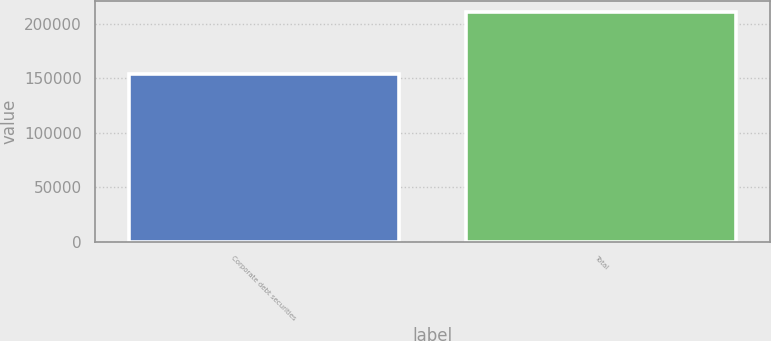Convert chart to OTSL. <chart><loc_0><loc_0><loc_500><loc_500><bar_chart><fcel>Corporate debt securities<fcel>Total<nl><fcel>153547<fcel>210870<nl></chart> 